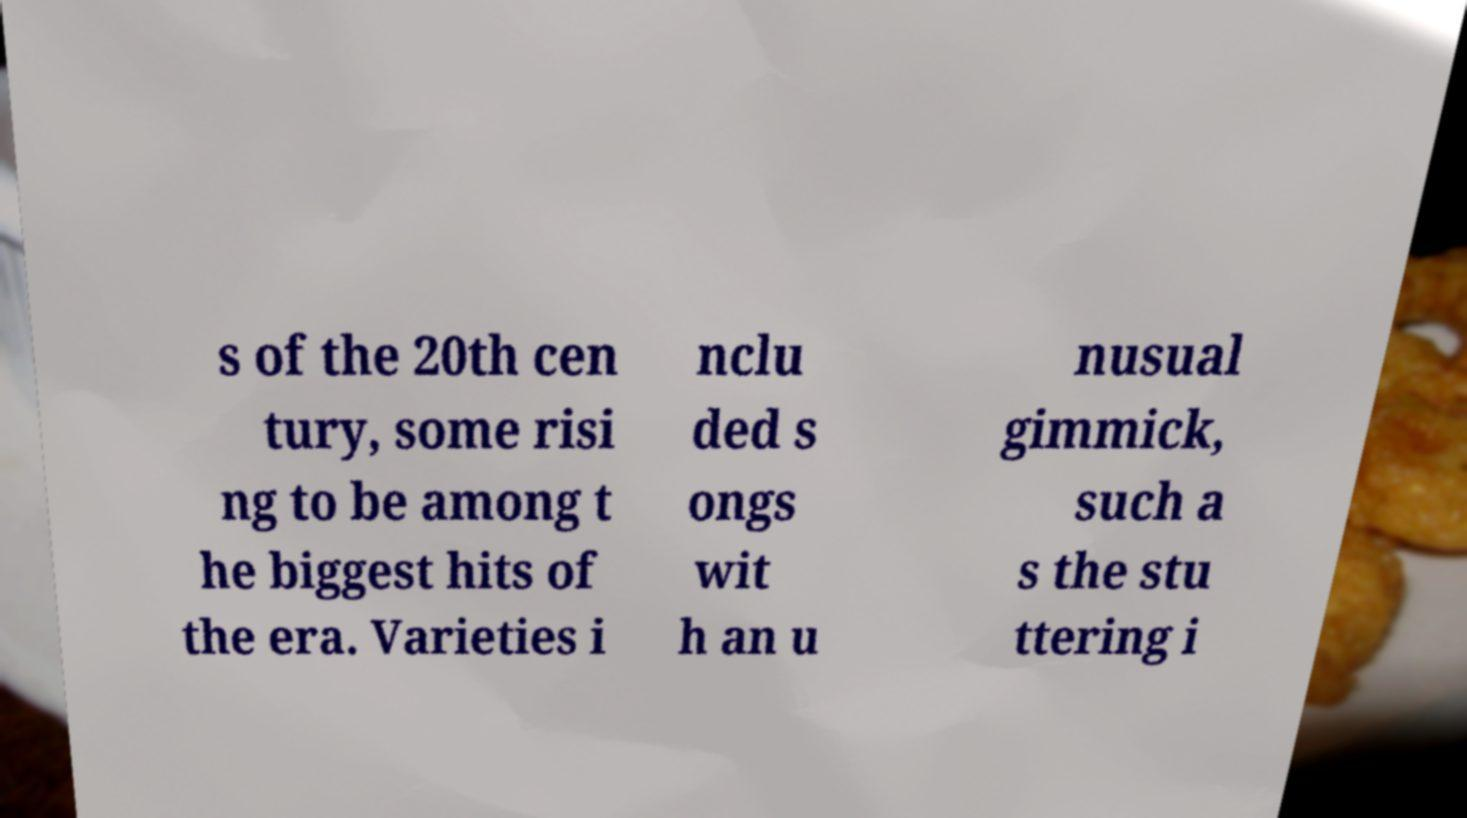What messages or text are displayed in this image? I need them in a readable, typed format. s of the 20th cen tury, some risi ng to be among t he biggest hits of the era. Varieties i nclu ded s ongs wit h an u nusual gimmick, such a s the stu ttering i 